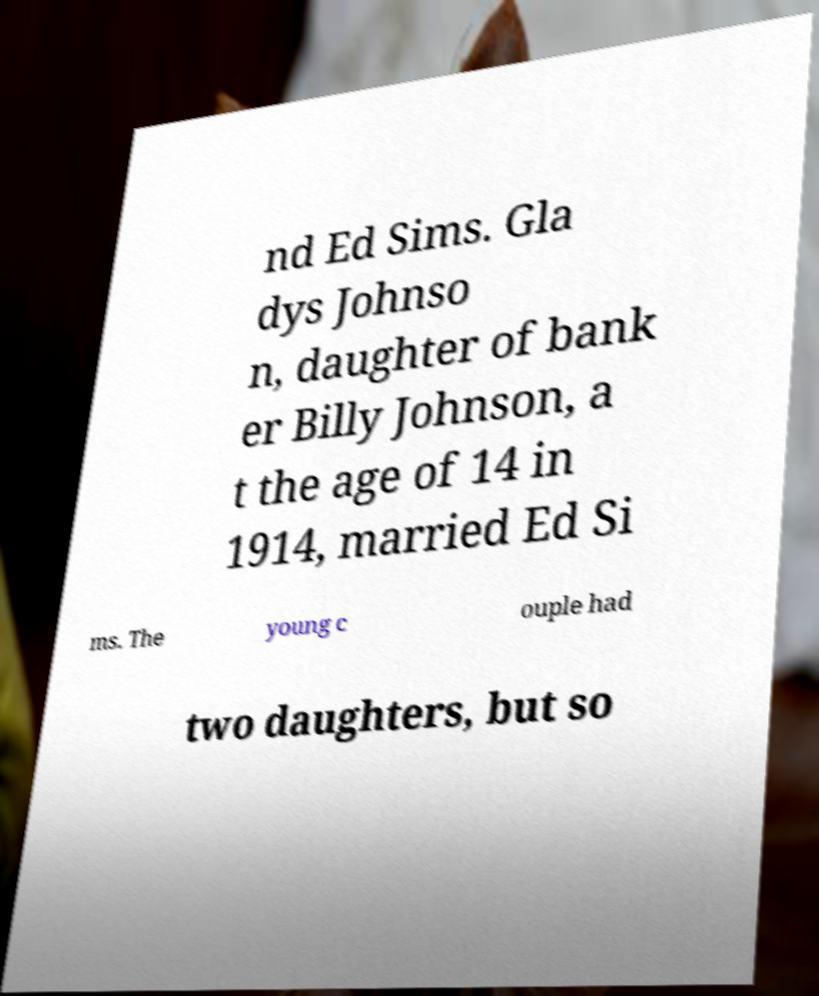Could you extract and type out the text from this image? nd Ed Sims. Gla dys Johnso n, daughter of bank er Billy Johnson, a t the age of 14 in 1914, married Ed Si ms. The young c ouple had two daughters, but so 